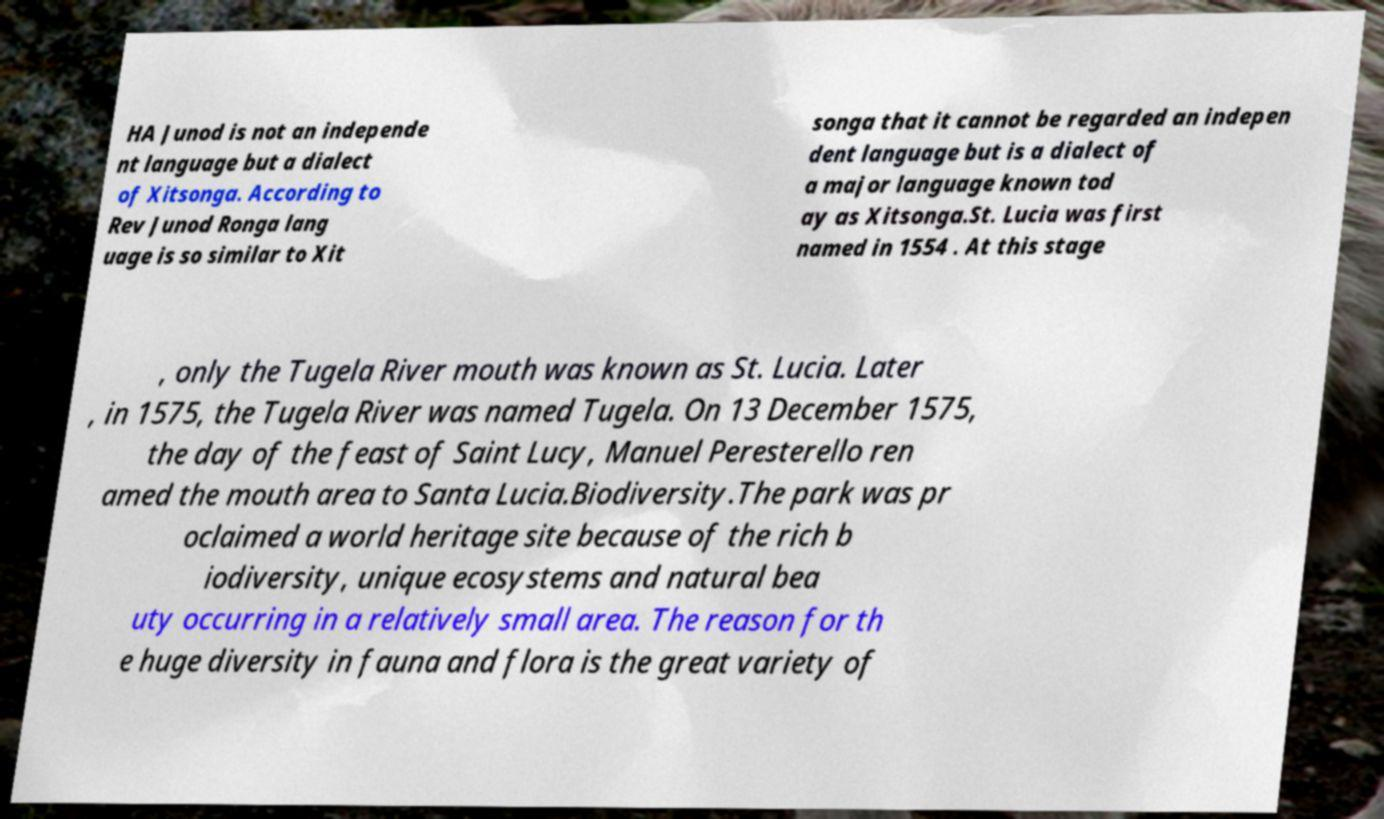Can you accurately transcribe the text from the provided image for me? HA Junod is not an independe nt language but a dialect of Xitsonga. According to Rev Junod Ronga lang uage is so similar to Xit songa that it cannot be regarded an indepen dent language but is a dialect of a major language known tod ay as Xitsonga.St. Lucia was first named in 1554 . At this stage , only the Tugela River mouth was known as St. Lucia. Later , in 1575, the Tugela River was named Tugela. On 13 December 1575, the day of the feast of Saint Lucy, Manuel Peresterello ren amed the mouth area to Santa Lucia.Biodiversity.The park was pr oclaimed a world heritage site because of the rich b iodiversity, unique ecosystems and natural bea uty occurring in a relatively small area. The reason for th e huge diversity in fauna and flora is the great variety of 